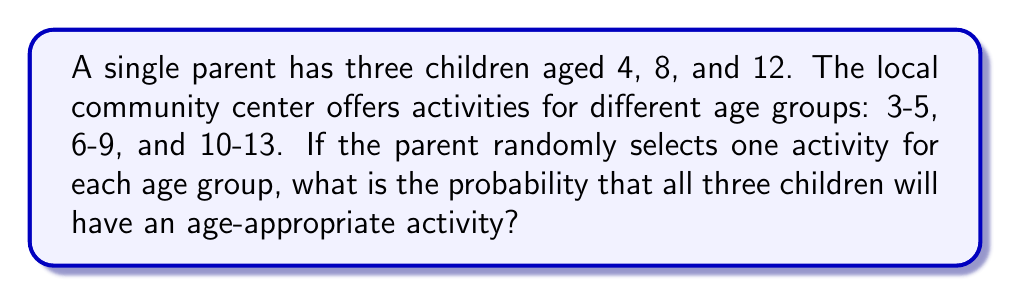Help me with this question. Let's approach this step-by-step:

1) First, we need to determine which age group each child belongs to:
   - 4-year-old: 3-5 age group
   - 8-year-old: 6-9 age group
   - 12-year-old: 10-13 age group

2) Now, we need to calculate the probability of selecting an appropriate activity for each child:
   - For the 4-year-old: $P(3-5) = 1$ (certainty)
   - For the 8-year-old: $P(6-9) = 1$ (certainty)
   - For the 12-year-old: $P(10-13) = 1$ (certainty)

3) The probability of all three events occurring together is the product of their individual probabilities:

   $$P(\text{all appropriate}) = P(3-5) \times P(6-9) \times P(10-13)$$
   $$P(\text{all appropriate}) = 1 \times 1 \times 1 = 1$$

4) Therefore, the probability of finding age-appropriate activities for all three children is 1, or 100%.

This result makes sense because each child falls into a different age group, and there is an activity available for each age group.
Answer: 1 or 100% 